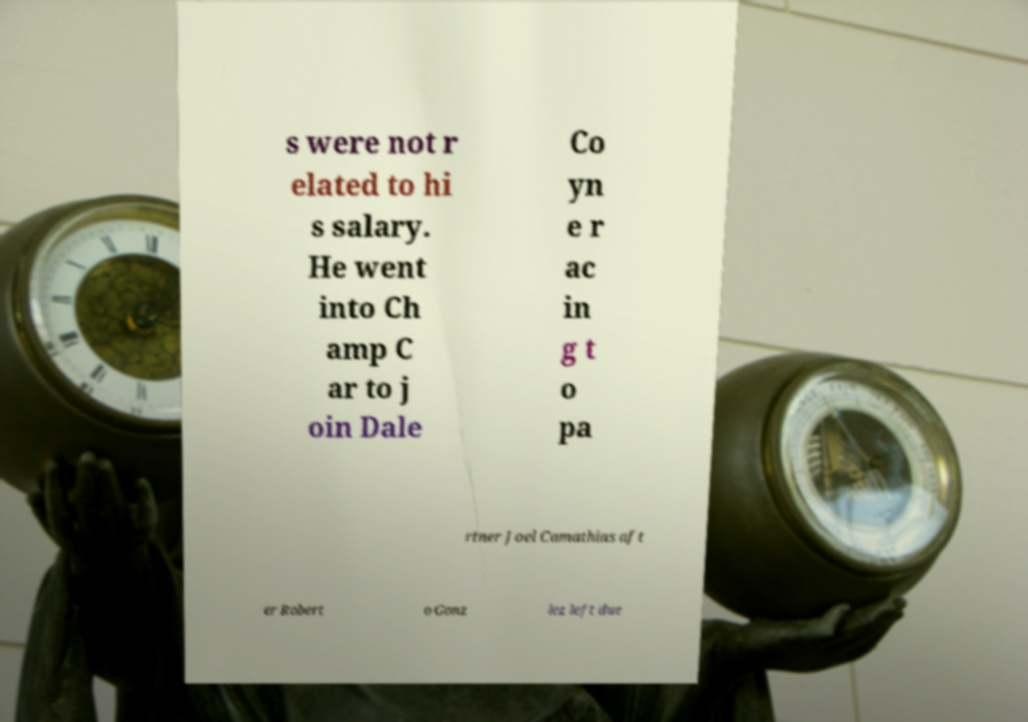I need the written content from this picture converted into text. Can you do that? s were not r elated to hi s salary. He went into Ch amp C ar to j oin Dale Co yn e r ac in g t o pa rtner Joel Camathias aft er Robert o Gonz lez left due 